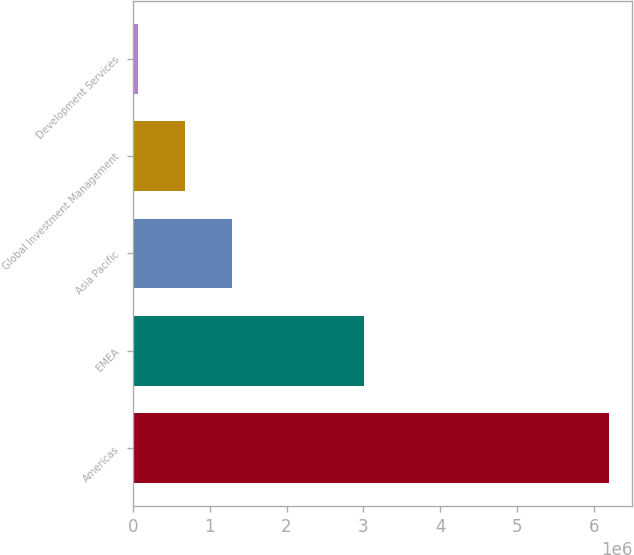Convert chart. <chart><loc_0><loc_0><loc_500><loc_500><bar_chart><fcel>Americas<fcel>EMEA<fcel>Asia Pacific<fcel>Global Investment Management<fcel>Development Services<nl><fcel>6.18991e+06<fcel>3.00448e+06<fcel>1.2905e+06<fcel>678070<fcel>65643<nl></chart> 